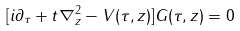<formula> <loc_0><loc_0><loc_500><loc_500>[ i \partial _ { \tau } + t \nabla _ { z } ^ { 2 } - V ( \tau , { z } ) ] G ( \tau , { z } ) = 0</formula> 